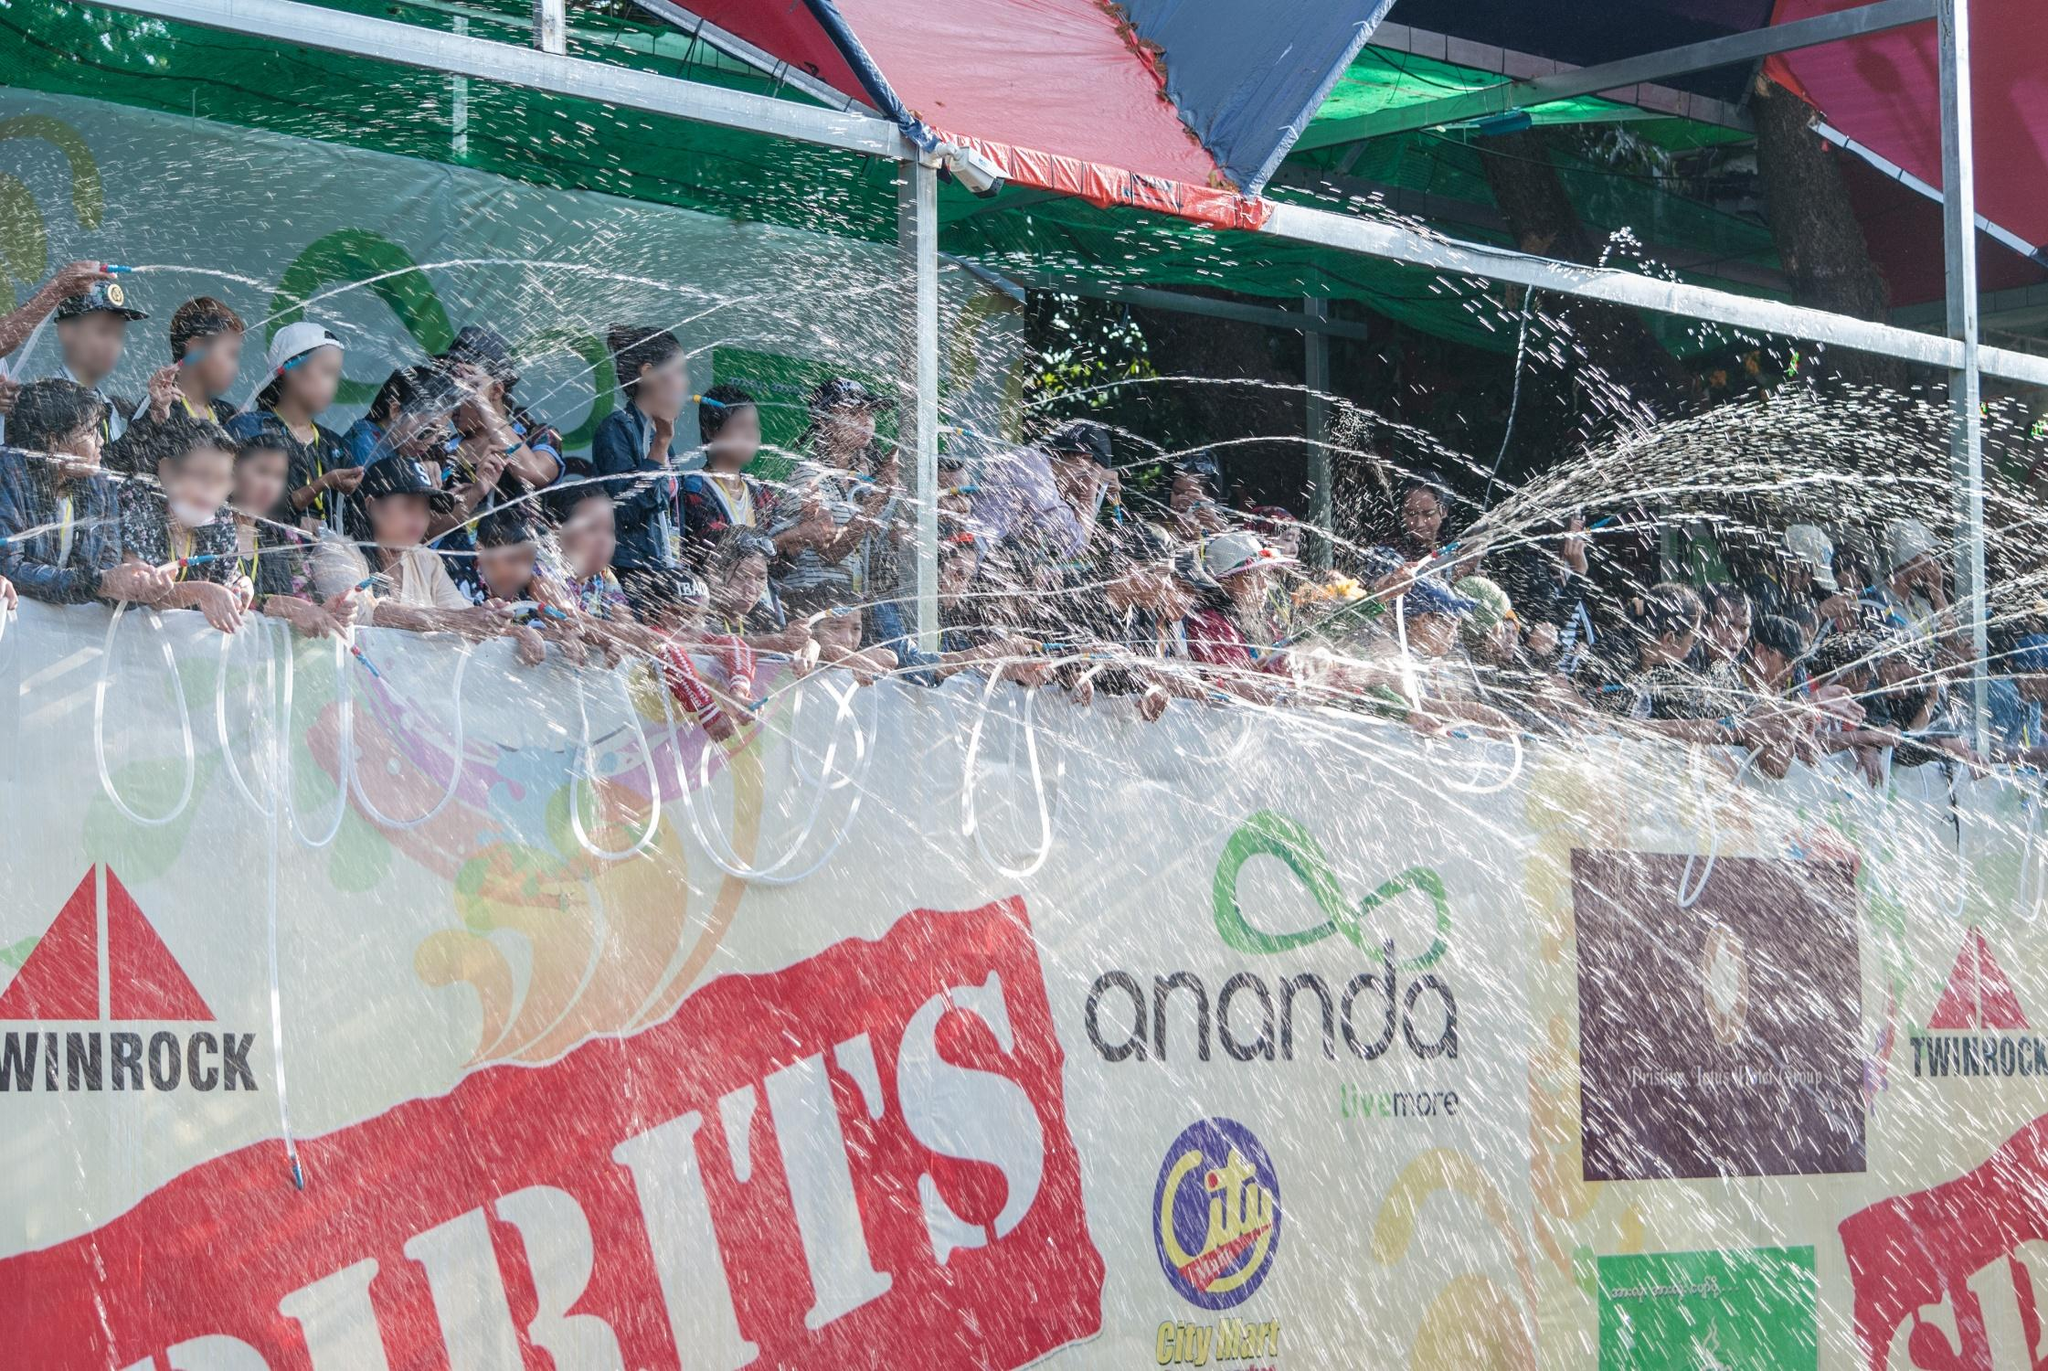Can you describe the activities happening in further detail? In this image, a large group of people is participating in a vibrant water fight aboard a decorated float. They are using hoses to spray water at the crowd, who are likely reciprocating enthusiastically. This playful interaction creates a series of dynamic water arcs in the air, adding energy and movement to the scene. The float itself is festooned with colorful banners and signs promoting various brands and messages, set against a vivid backdrop of red, green, yellow, and blue hues. This combination of lively human activity and bright decorations beautifully captures the essence of public celebration. The excitement is palpable, with smiles and laughter likely filling the air as everyone gets drenched in the spirit of fun and camaraderie. What sounds do you imagine hearing in this scene? In this scene, I imagine a cacophony of joyful sounds filling the air. The splashing of water, punctuated by squeals of delight and laughter, would be prevalent. You might hear the intermittent blasts of water hoses and the excited chatter of people as they engage in the water fight. The background might be filled with upbeat music, adding to the festive atmosphere, accompanied by the occasional shout or cheer as the water play intensifies. Vendors and participants might call out to each other, sharing in the communal joy. The overall soundscape would be one of vibrant energy, mirroring the exuberant visuals. 